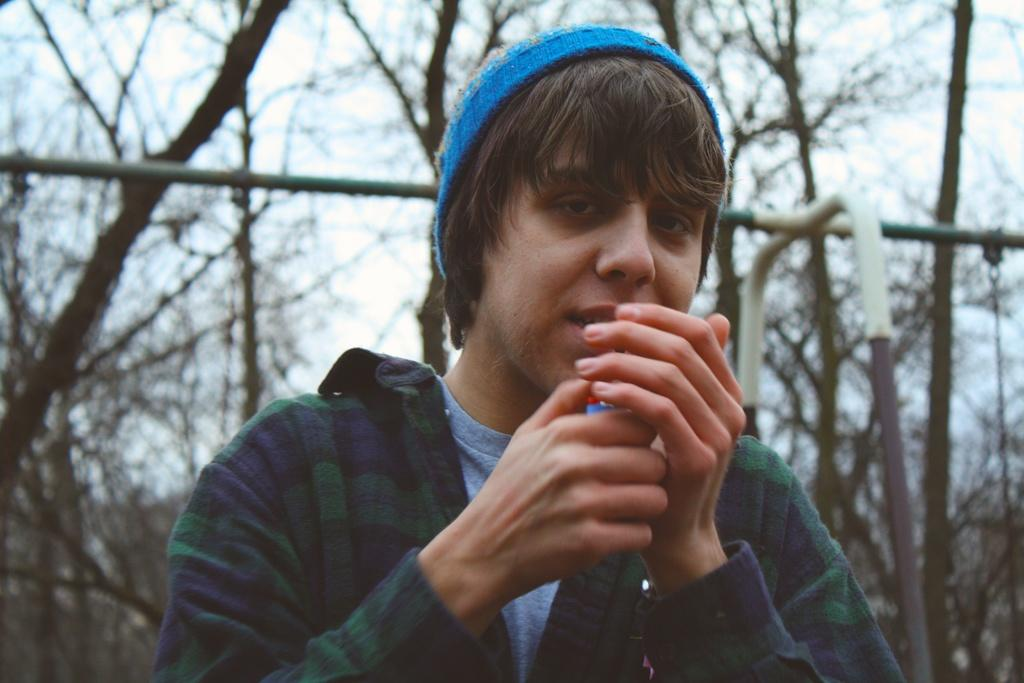What is present in the image? There is a person in the image. What is the person holding? The person is holding an object. What can be seen behind the person? There are metal rods behind the person. What is visible in the background of the image? There are trees and the sky in the background of the image. Can you hear the tiger whistling in the image? There is no tiger or whistling present in the image. 